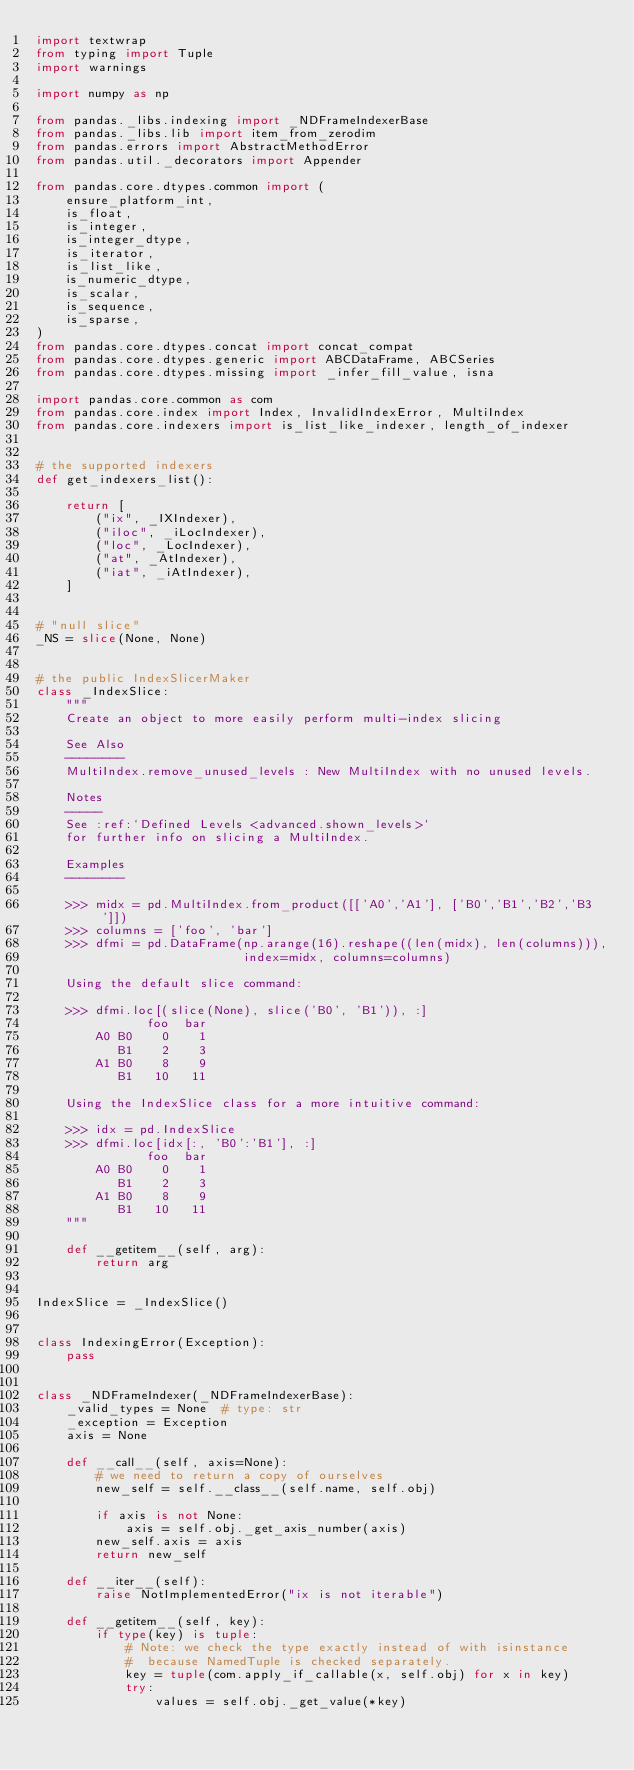<code> <loc_0><loc_0><loc_500><loc_500><_Python_>import textwrap
from typing import Tuple
import warnings

import numpy as np

from pandas._libs.indexing import _NDFrameIndexerBase
from pandas._libs.lib import item_from_zerodim
from pandas.errors import AbstractMethodError
from pandas.util._decorators import Appender

from pandas.core.dtypes.common import (
    ensure_platform_int,
    is_float,
    is_integer,
    is_integer_dtype,
    is_iterator,
    is_list_like,
    is_numeric_dtype,
    is_scalar,
    is_sequence,
    is_sparse,
)
from pandas.core.dtypes.concat import concat_compat
from pandas.core.dtypes.generic import ABCDataFrame, ABCSeries
from pandas.core.dtypes.missing import _infer_fill_value, isna

import pandas.core.common as com
from pandas.core.index import Index, InvalidIndexError, MultiIndex
from pandas.core.indexers import is_list_like_indexer, length_of_indexer


# the supported indexers
def get_indexers_list():

    return [
        ("ix", _IXIndexer),
        ("iloc", _iLocIndexer),
        ("loc", _LocIndexer),
        ("at", _AtIndexer),
        ("iat", _iAtIndexer),
    ]


# "null slice"
_NS = slice(None, None)


# the public IndexSlicerMaker
class _IndexSlice:
    """
    Create an object to more easily perform multi-index slicing

    See Also
    --------
    MultiIndex.remove_unused_levels : New MultiIndex with no unused levels.

    Notes
    -----
    See :ref:`Defined Levels <advanced.shown_levels>`
    for further info on slicing a MultiIndex.

    Examples
    --------

    >>> midx = pd.MultiIndex.from_product([['A0','A1'], ['B0','B1','B2','B3']])
    >>> columns = ['foo', 'bar']
    >>> dfmi = pd.DataFrame(np.arange(16).reshape((len(midx), len(columns))),
                            index=midx, columns=columns)

    Using the default slice command:

    >>> dfmi.loc[(slice(None), slice('B0', 'B1')), :]
               foo  bar
        A0 B0    0    1
           B1    2    3
        A1 B0    8    9
           B1   10   11

    Using the IndexSlice class for a more intuitive command:

    >>> idx = pd.IndexSlice
    >>> dfmi.loc[idx[:, 'B0':'B1'], :]
               foo  bar
        A0 B0    0    1
           B1    2    3
        A1 B0    8    9
           B1   10   11
    """

    def __getitem__(self, arg):
        return arg


IndexSlice = _IndexSlice()


class IndexingError(Exception):
    pass


class _NDFrameIndexer(_NDFrameIndexerBase):
    _valid_types = None  # type: str
    _exception = Exception
    axis = None

    def __call__(self, axis=None):
        # we need to return a copy of ourselves
        new_self = self.__class__(self.name, self.obj)

        if axis is not None:
            axis = self.obj._get_axis_number(axis)
        new_self.axis = axis
        return new_self

    def __iter__(self):
        raise NotImplementedError("ix is not iterable")

    def __getitem__(self, key):
        if type(key) is tuple:
            # Note: we check the type exactly instead of with isinstance
            #  because NamedTuple is checked separately.
            key = tuple(com.apply_if_callable(x, self.obj) for x in key)
            try:
                values = self.obj._get_value(*key)</code> 